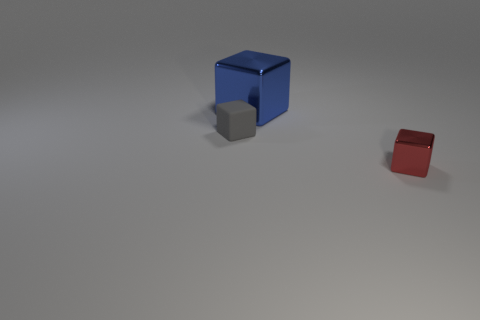Add 1 tiny gray rubber blocks. How many objects exist? 4 Add 3 tiny rubber objects. How many tiny rubber objects are left? 4 Add 1 tiny matte blocks. How many tiny matte blocks exist? 2 Subtract 0 green cubes. How many objects are left? 3 Subtract all big blue blocks. Subtract all tiny red cylinders. How many objects are left? 2 